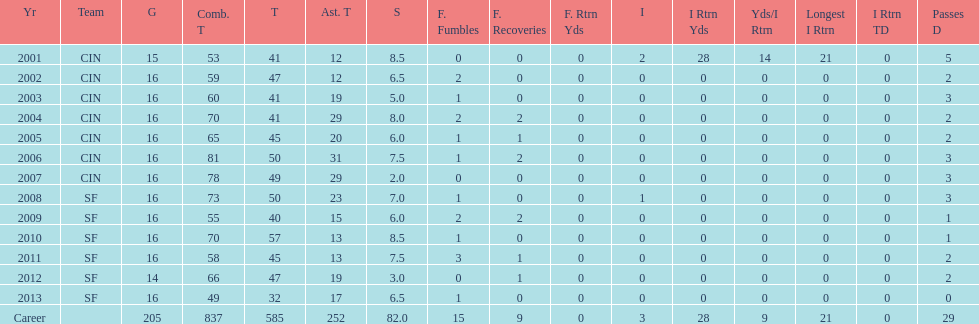How many sacks did this player have in his first five seasons? 34. 